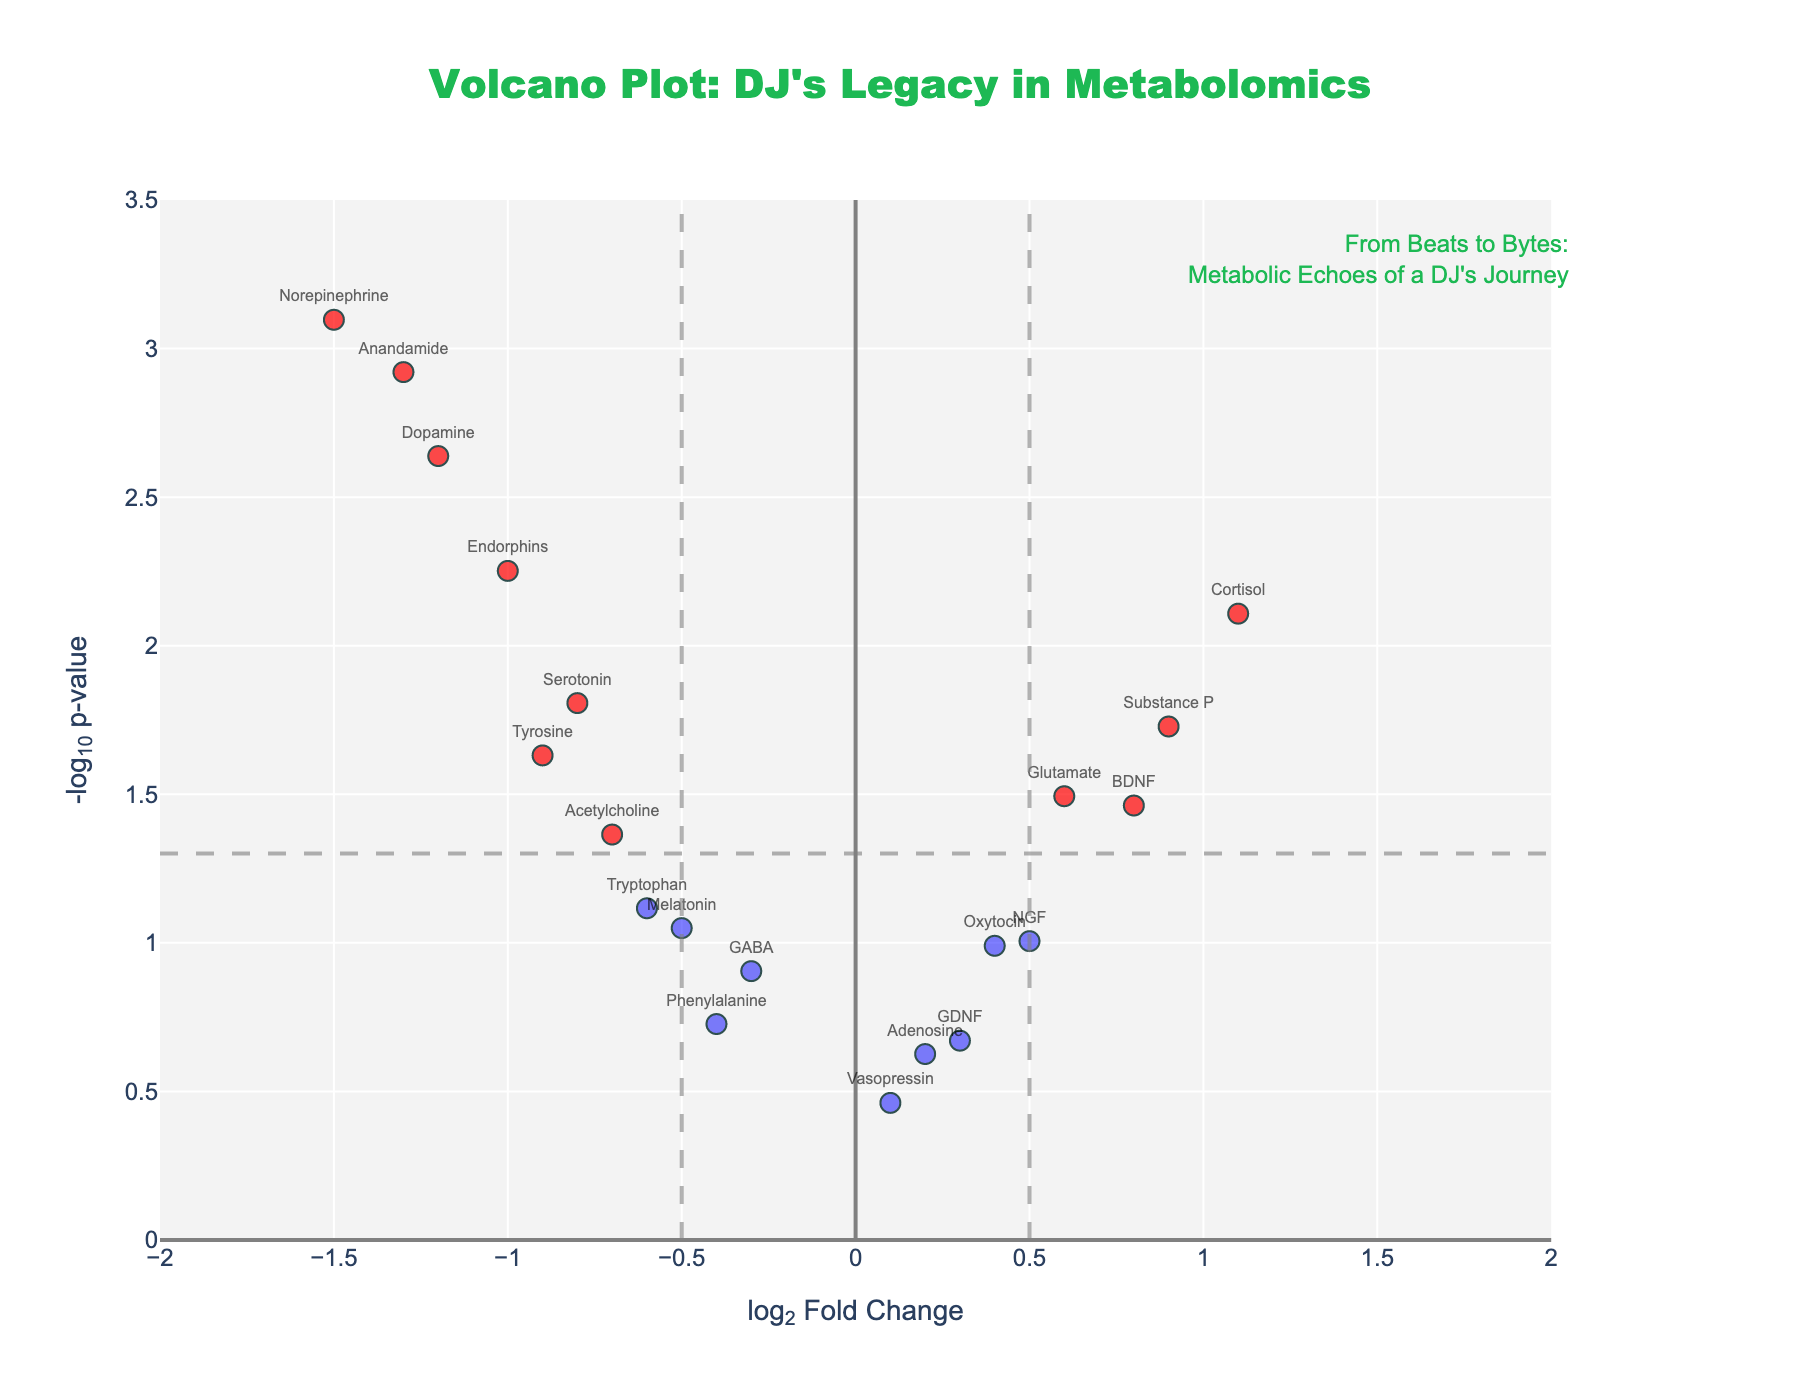How many metabolites are significantly different between the two groups? To determine the number of significantly different metabolites, look for those with points colored red. These are the metabolites that meet both thresholds: an absolute log2FoldChange greater than 0.5 and a p-value below 0.05, indicated by being above the horizontal dashed line and outside the vertical dashed lines. Count these points.
Answer: 10 Which metabolite has the highest log2FoldChange? Identify the point furthest to the right on the x-axis (log2FoldChange). The text label next to this point indicates the metabolite.
Answer: Cortisol What is the log2FoldChange and p-value of Anandamide? Locate the point labeled "Anandamide." Its x-coordinate represents the log2FoldChange, and its y-coordinate represents the -log10(p-value). The p-value can be recovered by reversing the -log10 transformation.
Answer: -1.3 and 0.0012 How many metabolites have a log2FoldChange greater than 0.5 but are not statistically significant? Look for points with a log2FoldChange greater than 0.5 (right of the center line) but below the horizontal dashed line (p-value not significant). This will determine how many meet the fold-change criterion but not significance.
Answer: 2 Which three metabolites have the smallest p-values? To find the smallest p-values, locate the three highest points on the y-axis (-log10(p-value)). The text labels next to these points indicate the metabolites.
Answer: Norepinephrine, Anandamide, Dopamine How does the fold change of Endorphins compare to that of Serotonin? Locate the points labeled "Endorphins" and "Serotonin." Compare their x-coordinates (log2FoldChange). A more negative value indicates a larger fold reduction.
Answer: Endorphins have a larger fold reduction than Serotonin Which metabolites fall within the fold change threshold, but are not statistically significant? Locate points within the vertical dashed lines (-0.5 < log2FoldChange < 0.5) and below the horizontal dashed line. The text labels next to these points indicate the metabolites.
Answer: GABA, Melatonin, Adenosine, Vasopressin, Phenylalanine, GDNF What is the relationship between Substance P and Acetylcholine regarding their significance and fold change? Find the points labeled "Substance P" and "Acetylcholine." Compare their x-coordinates (log2FoldChange) and y-coordinates (-log10(p-value)). Determine which is more significant and which has a higher fold change.
Answer: Substance P has a higher positive fold change and is more significant than Acetylcholine How many metabolites have a log2FoldChange less than -0.5 and are statistically significant? Identify points to the left of the -0.5 threshold and above the horizontal dashed line. Count these points.
Answer: 7 